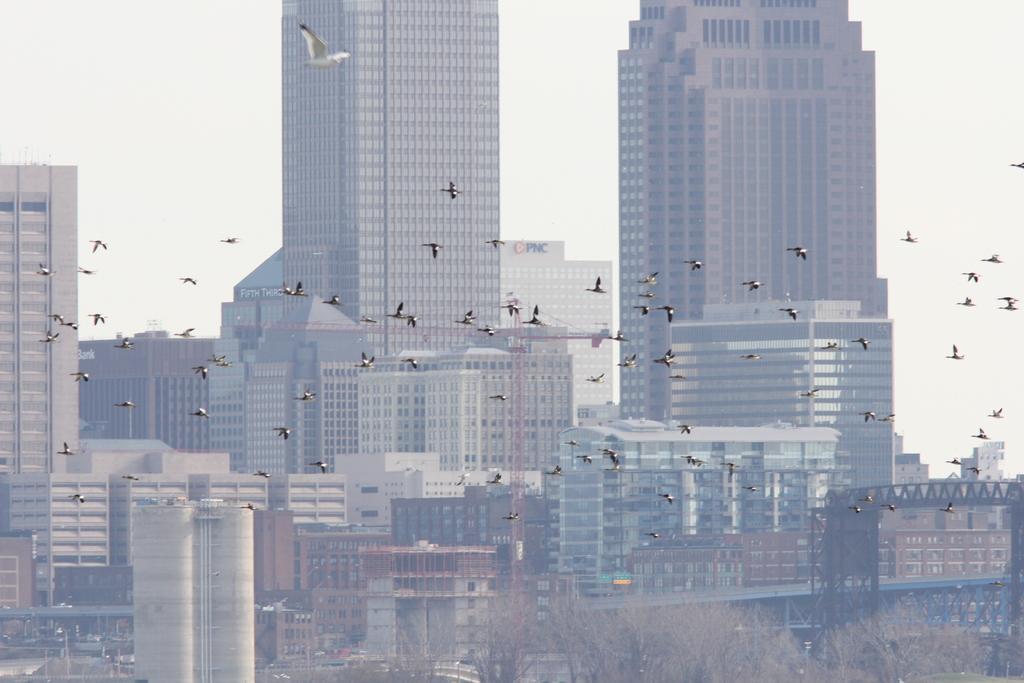How would you summarize this image in a sentence or two? In the middle of the image some birds are flying. Behind the bird there are some buildings. At the bottom of the image there are some trees. Behind the building there is sky. 